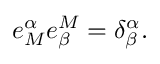<formula> <loc_0><loc_0><loc_500><loc_500>e _ { M } ^ { \alpha } e _ { \beta } ^ { M } = \delta _ { \beta } ^ { \alpha } .</formula> 